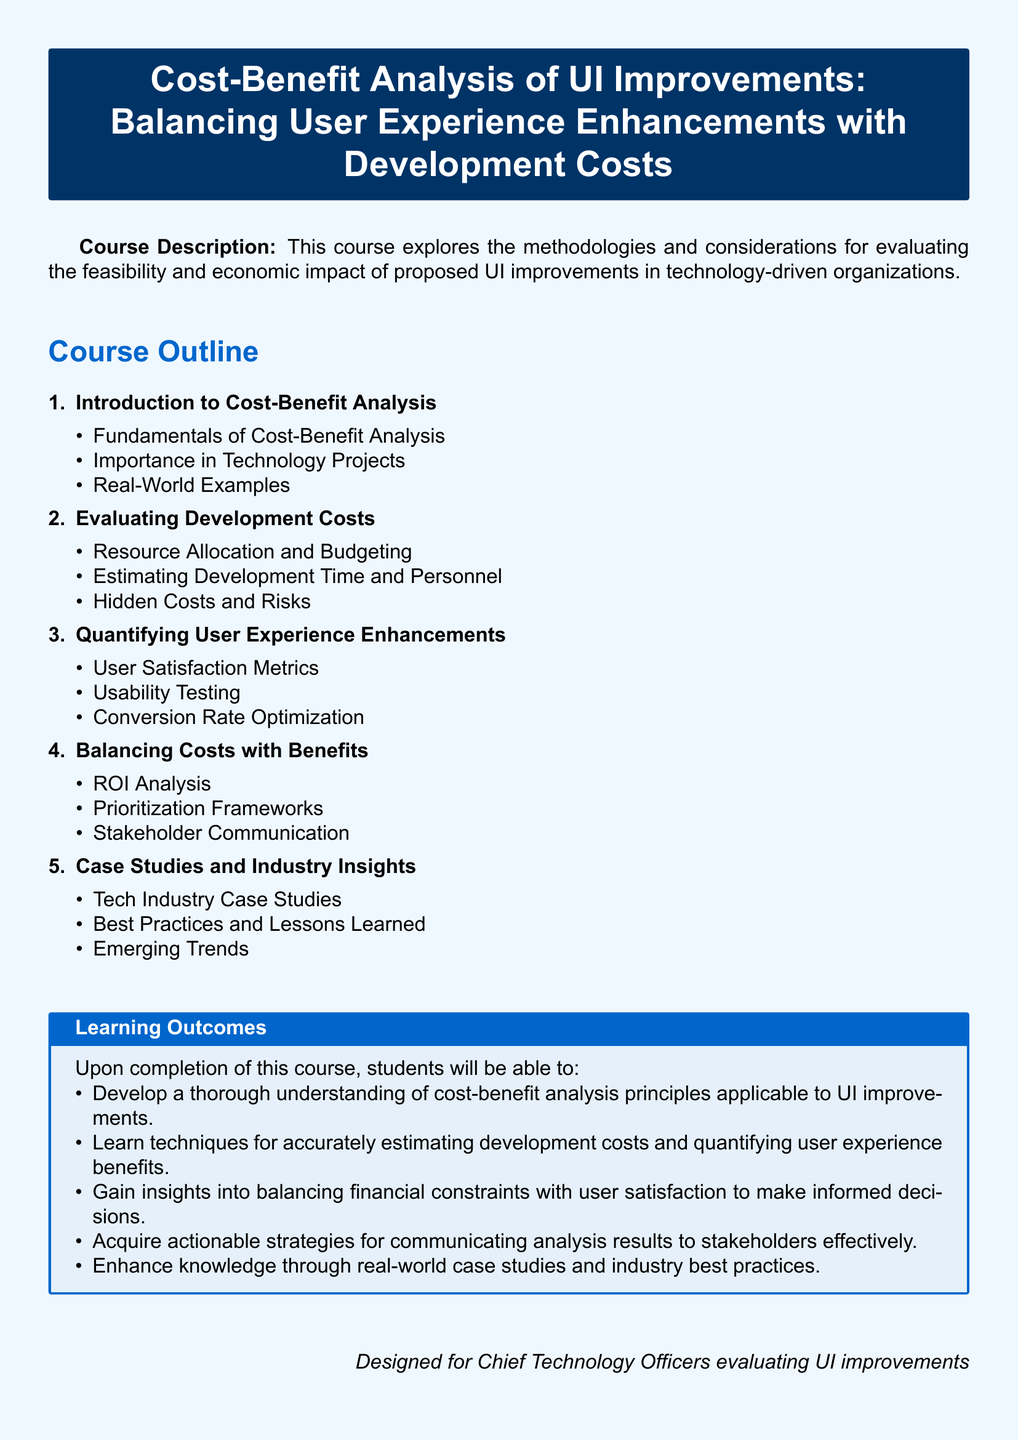What is the course title? The course title is explicitly stated at the beginning of the document.
Answer: Cost-Benefit Analysis of UI Improvements: Balancing User Experience Enhancements with Development Costs What is the first topic in the course outline? The first topic in the course outline introduces fundamental concepts related to cost-benefit analysis.
Answer: Introduction to Cost-Benefit Analysis How many learning outcomes are listed? The number of learning outcomes is directly presented under the Learning Outcomes section.
Answer: Five What is emphasized in the second section of the course outline? The second section focuses on assessing and calculating expenses associated with development.
Answer: Evaluating Development Costs What will students gain insights into upon completion of the course? The document specifies that students will learn about financial constraints and user satisfaction balance.
Answer: Balancing financial constraints with user satisfaction What type of document is this? It is important to understand the nature of the document to categorize its content properly.
Answer: Syllabus What is one method used for quantifying user experience enhancements? The syllabus mentions several techniques for measurement, one of which is highlighted here.
Answer: Usability Testing What is a key aspect mentioned in the last section of the course outline? The last section highlights practical examples and approaches from the technology industry.
Answer: Case Studies and Industry Insights 